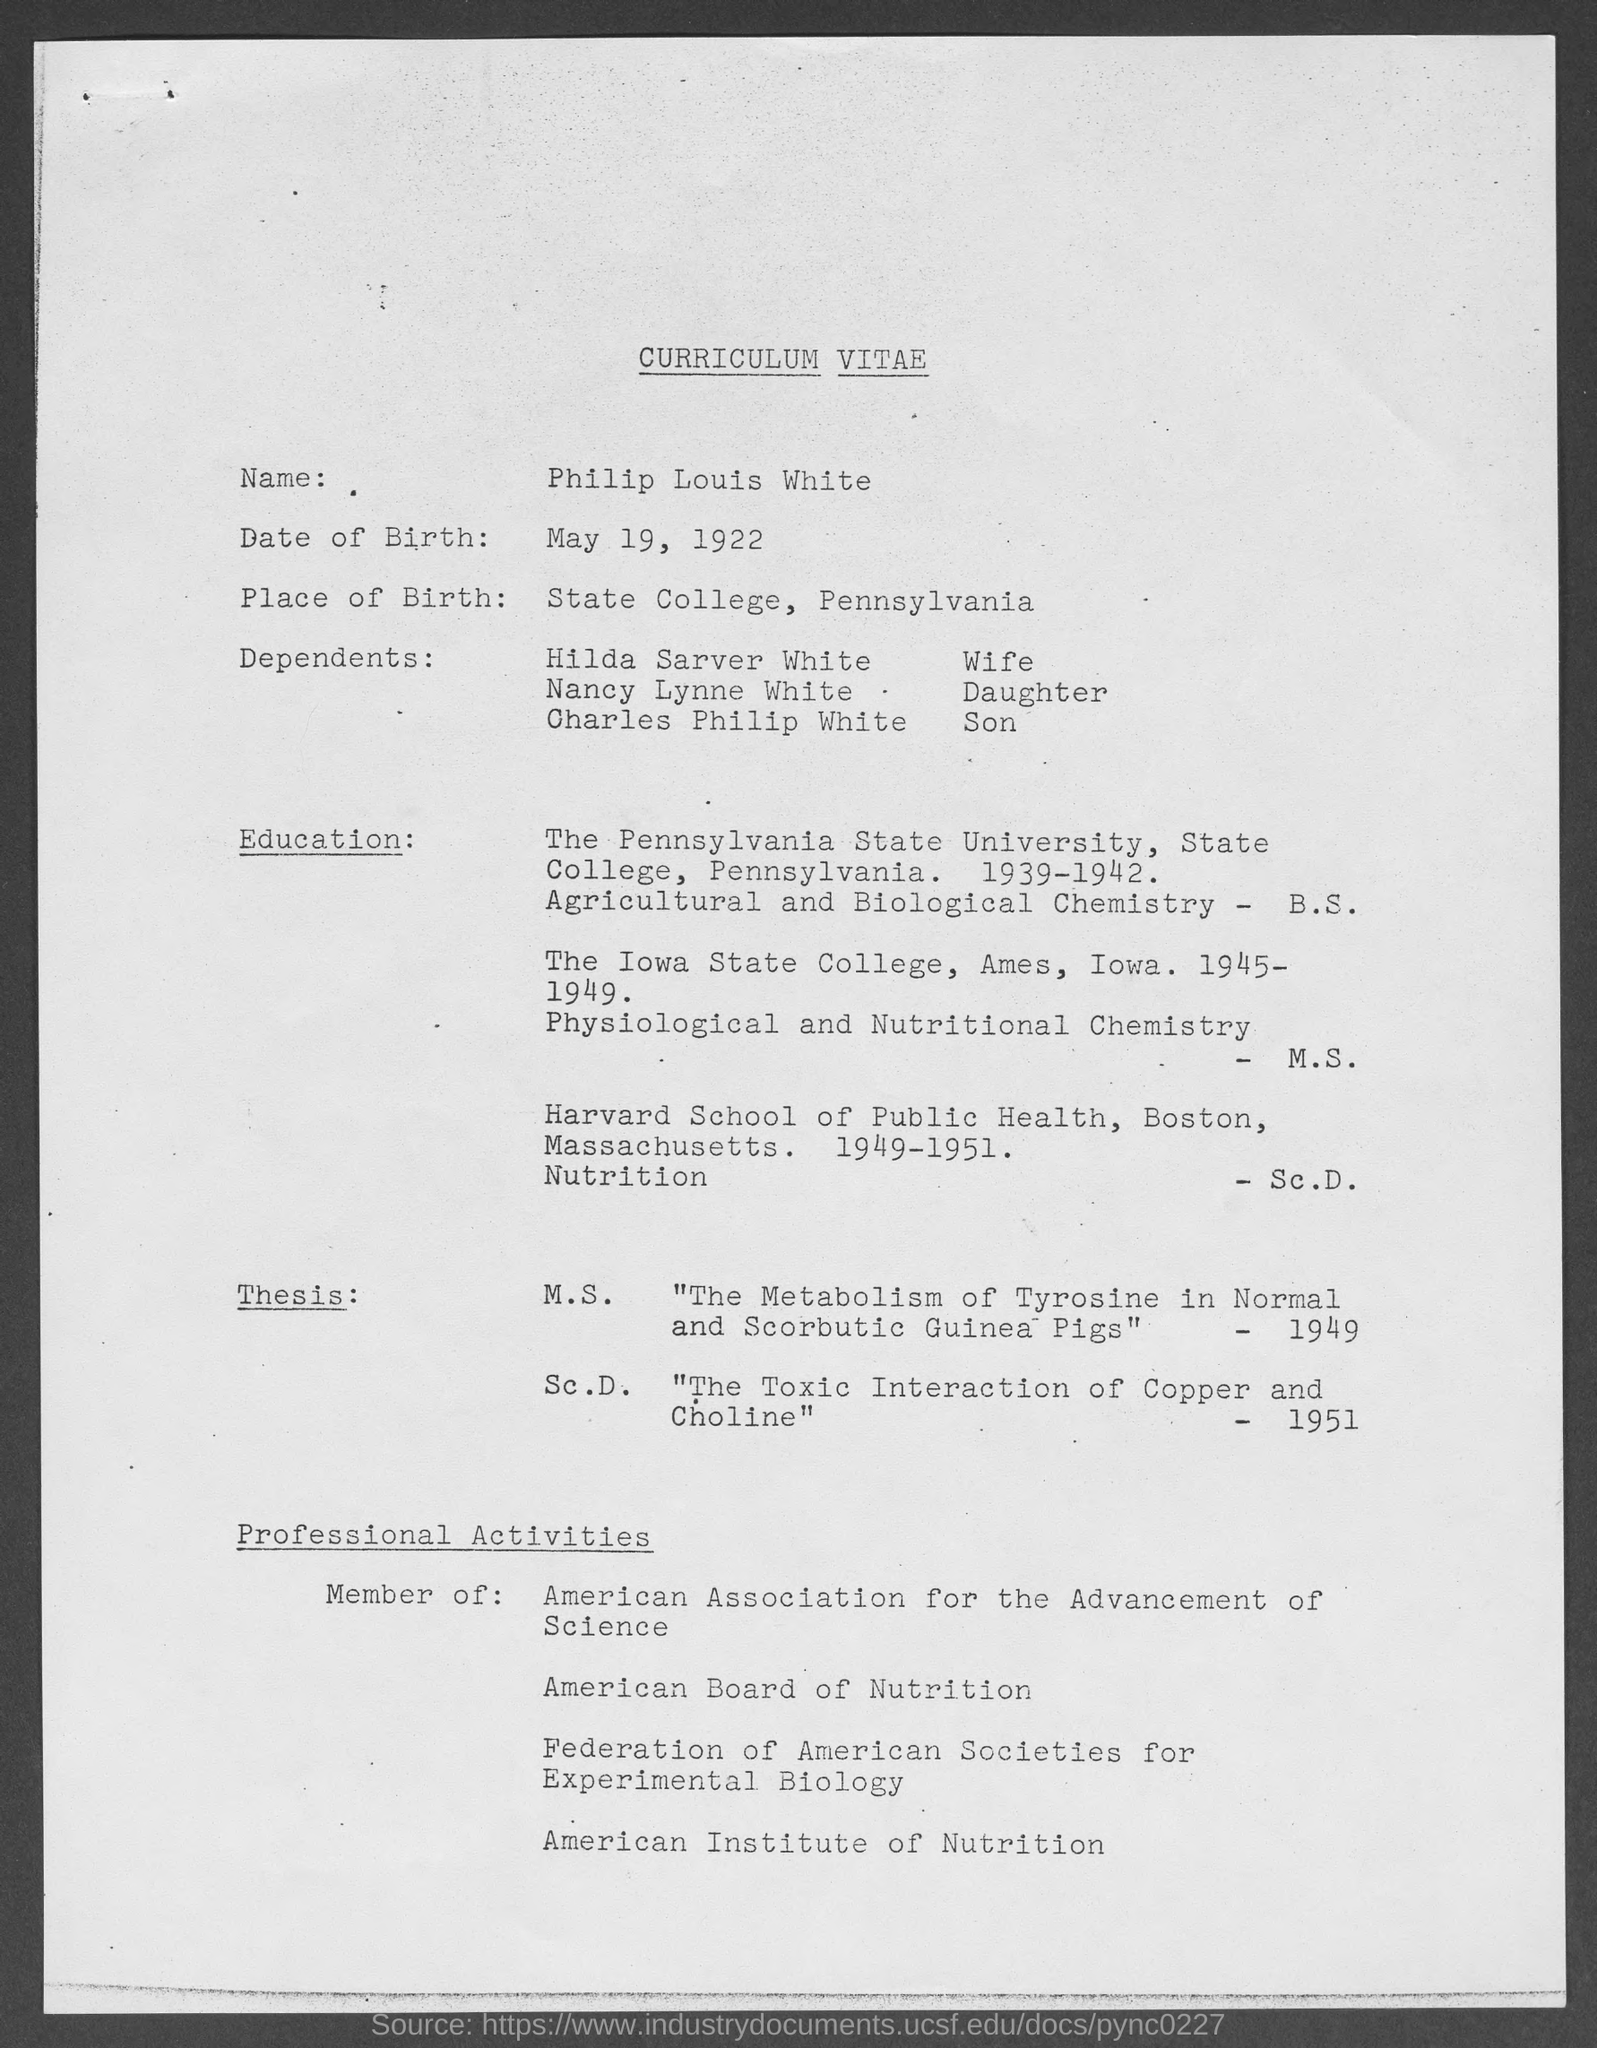What is date of birth?
Provide a succinct answer. May 19, 1922. Where is place of birth?
Give a very brief answer. State College, Pennsylvania. Whose curriculum vitae it is?
Provide a succinct answer. Philip Louis White. 